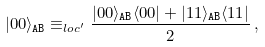Convert formula to latex. <formula><loc_0><loc_0><loc_500><loc_500>| 0 0 \rangle _ { \tt A B } \equiv _ { l o c ^ { \prime } } \frac { | 0 0 \rangle _ { \tt A B } \langle 0 0 | + | 1 1 \rangle _ { \tt A B } \langle 1 1 | } { 2 } \, ,</formula> 